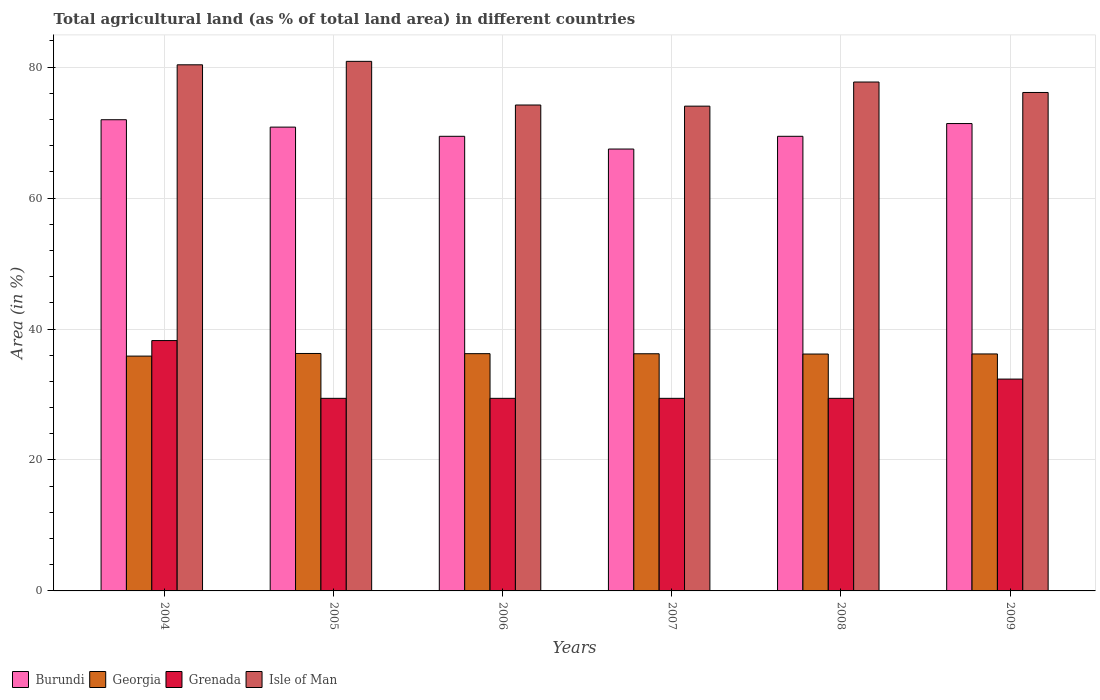Are the number of bars per tick equal to the number of legend labels?
Keep it short and to the point. Yes. How many bars are there on the 6th tick from the left?
Offer a very short reply. 4. What is the label of the 6th group of bars from the left?
Offer a very short reply. 2009. What is the percentage of agricultural land in Burundi in 2007?
Offer a terse response. 67.48. Across all years, what is the maximum percentage of agricultural land in Grenada?
Your response must be concise. 38.24. Across all years, what is the minimum percentage of agricultural land in Georgia?
Your answer should be compact. 35.86. In which year was the percentage of agricultural land in Grenada minimum?
Your response must be concise. 2005. What is the total percentage of agricultural land in Georgia in the graph?
Make the answer very short. 216.95. What is the difference between the percentage of agricultural land in Burundi in 2005 and that in 2008?
Your answer should be very brief. 1.4. What is the difference between the percentage of agricultural land in Burundi in 2007 and the percentage of agricultural land in Georgia in 2009?
Offer a very short reply. 31.29. What is the average percentage of agricultural land in Burundi per year?
Your answer should be compact. 70.09. In the year 2008, what is the difference between the percentage of agricultural land in Burundi and percentage of agricultural land in Georgia?
Offer a terse response. 33.25. What is the ratio of the percentage of agricultural land in Burundi in 2005 to that in 2008?
Give a very brief answer. 1.02. Is the percentage of agricultural land in Isle of Man in 2005 less than that in 2006?
Your answer should be compact. No. Is the difference between the percentage of agricultural land in Burundi in 2005 and 2007 greater than the difference between the percentage of agricultural land in Georgia in 2005 and 2007?
Provide a short and direct response. Yes. What is the difference between the highest and the second highest percentage of agricultural land in Isle of Man?
Offer a terse response. 0.53. What is the difference between the highest and the lowest percentage of agricultural land in Georgia?
Offer a terse response. 0.4. Is it the case that in every year, the sum of the percentage of agricultural land in Burundi and percentage of agricultural land in Georgia is greater than the sum of percentage of agricultural land in Isle of Man and percentage of agricultural land in Grenada?
Offer a terse response. Yes. What does the 4th bar from the left in 2006 represents?
Make the answer very short. Isle of Man. What does the 4th bar from the right in 2008 represents?
Your response must be concise. Burundi. Are all the bars in the graph horizontal?
Keep it short and to the point. No. How many years are there in the graph?
Your response must be concise. 6. Are the values on the major ticks of Y-axis written in scientific E-notation?
Give a very brief answer. No. Does the graph contain any zero values?
Ensure brevity in your answer.  No. How many legend labels are there?
Provide a succinct answer. 4. How are the legend labels stacked?
Make the answer very short. Horizontal. What is the title of the graph?
Keep it short and to the point. Total agricultural land (as % of total land area) in different countries. Does "Algeria" appear as one of the legend labels in the graph?
Your answer should be compact. No. What is the label or title of the X-axis?
Provide a succinct answer. Years. What is the label or title of the Y-axis?
Provide a short and direct response. Area (in %). What is the Area (in %) in Burundi in 2004?
Your answer should be compact. 71.96. What is the Area (in %) in Georgia in 2004?
Provide a short and direct response. 35.86. What is the Area (in %) in Grenada in 2004?
Keep it short and to the point. 38.24. What is the Area (in %) in Isle of Man in 2004?
Offer a very short reply. 80.35. What is the Area (in %) of Burundi in 2005?
Offer a terse response. 70.83. What is the Area (in %) in Georgia in 2005?
Give a very brief answer. 36.26. What is the Area (in %) in Grenada in 2005?
Provide a succinct answer. 29.41. What is the Area (in %) in Isle of Man in 2005?
Your answer should be very brief. 80.88. What is the Area (in %) of Burundi in 2006?
Offer a terse response. 69.43. What is the Area (in %) in Georgia in 2006?
Give a very brief answer. 36.24. What is the Area (in %) in Grenada in 2006?
Give a very brief answer. 29.41. What is the Area (in %) in Isle of Man in 2006?
Provide a succinct answer. 74.21. What is the Area (in %) of Burundi in 2007?
Your response must be concise. 67.48. What is the Area (in %) in Georgia in 2007?
Offer a very short reply. 36.22. What is the Area (in %) in Grenada in 2007?
Your answer should be compact. 29.41. What is the Area (in %) in Isle of Man in 2007?
Your answer should be very brief. 74.04. What is the Area (in %) in Burundi in 2008?
Give a very brief answer. 69.43. What is the Area (in %) of Georgia in 2008?
Make the answer very short. 36.18. What is the Area (in %) in Grenada in 2008?
Ensure brevity in your answer.  29.41. What is the Area (in %) in Isle of Man in 2008?
Offer a terse response. 77.72. What is the Area (in %) in Burundi in 2009?
Your answer should be very brief. 71.38. What is the Area (in %) in Georgia in 2009?
Make the answer very short. 36.19. What is the Area (in %) in Grenada in 2009?
Make the answer very short. 32.35. What is the Area (in %) of Isle of Man in 2009?
Offer a very short reply. 76.12. Across all years, what is the maximum Area (in %) in Burundi?
Give a very brief answer. 71.96. Across all years, what is the maximum Area (in %) of Georgia?
Ensure brevity in your answer.  36.26. Across all years, what is the maximum Area (in %) of Grenada?
Ensure brevity in your answer.  38.24. Across all years, what is the maximum Area (in %) of Isle of Man?
Your response must be concise. 80.88. Across all years, what is the minimum Area (in %) in Burundi?
Provide a succinct answer. 67.48. Across all years, what is the minimum Area (in %) of Georgia?
Make the answer very short. 35.86. Across all years, what is the minimum Area (in %) of Grenada?
Keep it short and to the point. 29.41. Across all years, what is the minimum Area (in %) in Isle of Man?
Give a very brief answer. 74.04. What is the total Area (in %) of Burundi in the graph?
Offer a terse response. 420.52. What is the total Area (in %) of Georgia in the graph?
Ensure brevity in your answer.  216.95. What is the total Area (in %) of Grenada in the graph?
Make the answer very short. 188.24. What is the total Area (in %) of Isle of Man in the graph?
Keep it short and to the point. 463.32. What is the difference between the Area (in %) of Burundi in 2004 and that in 2005?
Offer a very short reply. 1.13. What is the difference between the Area (in %) of Georgia in 2004 and that in 2005?
Your response must be concise. -0.4. What is the difference between the Area (in %) in Grenada in 2004 and that in 2005?
Ensure brevity in your answer.  8.82. What is the difference between the Area (in %) in Isle of Man in 2004 and that in 2005?
Your response must be concise. -0.53. What is the difference between the Area (in %) in Burundi in 2004 and that in 2006?
Your answer should be very brief. 2.53. What is the difference between the Area (in %) of Georgia in 2004 and that in 2006?
Offer a terse response. -0.37. What is the difference between the Area (in %) in Grenada in 2004 and that in 2006?
Offer a terse response. 8.82. What is the difference between the Area (in %) in Isle of Man in 2004 and that in 2006?
Offer a very short reply. 6.14. What is the difference between the Area (in %) of Burundi in 2004 and that in 2007?
Your answer should be compact. 4.48. What is the difference between the Area (in %) in Georgia in 2004 and that in 2007?
Provide a succinct answer. -0.36. What is the difference between the Area (in %) of Grenada in 2004 and that in 2007?
Provide a succinct answer. 8.82. What is the difference between the Area (in %) of Isle of Man in 2004 and that in 2007?
Provide a succinct answer. 6.32. What is the difference between the Area (in %) in Burundi in 2004 and that in 2008?
Provide a succinct answer. 2.53. What is the difference between the Area (in %) in Georgia in 2004 and that in 2008?
Make the answer very short. -0.32. What is the difference between the Area (in %) of Grenada in 2004 and that in 2008?
Ensure brevity in your answer.  8.82. What is the difference between the Area (in %) in Isle of Man in 2004 and that in 2008?
Your answer should be compact. 2.63. What is the difference between the Area (in %) in Burundi in 2004 and that in 2009?
Provide a succinct answer. 0.58. What is the difference between the Area (in %) of Georgia in 2004 and that in 2009?
Make the answer very short. -0.33. What is the difference between the Area (in %) of Grenada in 2004 and that in 2009?
Make the answer very short. 5.88. What is the difference between the Area (in %) of Isle of Man in 2004 and that in 2009?
Your answer should be very brief. 4.23. What is the difference between the Area (in %) in Burundi in 2005 and that in 2006?
Offer a very short reply. 1.4. What is the difference between the Area (in %) of Georgia in 2005 and that in 2006?
Give a very brief answer. 0.03. What is the difference between the Area (in %) in Burundi in 2005 and that in 2007?
Offer a very short reply. 3.35. What is the difference between the Area (in %) in Georgia in 2005 and that in 2007?
Provide a short and direct response. 0.04. What is the difference between the Area (in %) of Isle of Man in 2005 and that in 2007?
Offer a very short reply. 6.84. What is the difference between the Area (in %) in Burundi in 2005 and that in 2008?
Your answer should be very brief. 1.4. What is the difference between the Area (in %) of Georgia in 2005 and that in 2008?
Your answer should be very brief. 0.09. What is the difference between the Area (in %) of Isle of Man in 2005 and that in 2008?
Provide a succinct answer. 3.16. What is the difference between the Area (in %) in Burundi in 2005 and that in 2009?
Your answer should be very brief. -0.55. What is the difference between the Area (in %) of Georgia in 2005 and that in 2009?
Give a very brief answer. 0.07. What is the difference between the Area (in %) in Grenada in 2005 and that in 2009?
Provide a succinct answer. -2.94. What is the difference between the Area (in %) of Isle of Man in 2005 and that in 2009?
Your answer should be very brief. 4.75. What is the difference between the Area (in %) of Burundi in 2006 and that in 2007?
Ensure brevity in your answer.  1.95. What is the difference between the Area (in %) of Georgia in 2006 and that in 2007?
Offer a very short reply. 0.01. What is the difference between the Area (in %) of Grenada in 2006 and that in 2007?
Your response must be concise. 0. What is the difference between the Area (in %) of Isle of Man in 2006 and that in 2007?
Provide a succinct answer. 0.18. What is the difference between the Area (in %) of Georgia in 2006 and that in 2008?
Provide a short and direct response. 0.06. What is the difference between the Area (in %) of Grenada in 2006 and that in 2008?
Give a very brief answer. 0. What is the difference between the Area (in %) of Isle of Man in 2006 and that in 2008?
Your response must be concise. -3.51. What is the difference between the Area (in %) of Burundi in 2006 and that in 2009?
Your answer should be very brief. -1.95. What is the difference between the Area (in %) in Georgia in 2006 and that in 2009?
Offer a very short reply. 0.04. What is the difference between the Area (in %) in Grenada in 2006 and that in 2009?
Offer a terse response. -2.94. What is the difference between the Area (in %) in Isle of Man in 2006 and that in 2009?
Ensure brevity in your answer.  -1.91. What is the difference between the Area (in %) of Burundi in 2007 and that in 2008?
Keep it short and to the point. -1.95. What is the difference between the Area (in %) in Georgia in 2007 and that in 2008?
Offer a terse response. 0.04. What is the difference between the Area (in %) in Isle of Man in 2007 and that in 2008?
Provide a short and direct response. -3.68. What is the difference between the Area (in %) of Burundi in 2007 and that in 2009?
Your answer should be compact. -3.89. What is the difference between the Area (in %) in Georgia in 2007 and that in 2009?
Offer a terse response. 0.03. What is the difference between the Area (in %) of Grenada in 2007 and that in 2009?
Ensure brevity in your answer.  -2.94. What is the difference between the Area (in %) of Isle of Man in 2007 and that in 2009?
Provide a succinct answer. -2.09. What is the difference between the Area (in %) in Burundi in 2008 and that in 2009?
Offer a terse response. -1.95. What is the difference between the Area (in %) in Georgia in 2008 and that in 2009?
Provide a short and direct response. -0.01. What is the difference between the Area (in %) in Grenada in 2008 and that in 2009?
Keep it short and to the point. -2.94. What is the difference between the Area (in %) in Isle of Man in 2008 and that in 2009?
Provide a short and direct response. 1.6. What is the difference between the Area (in %) in Burundi in 2004 and the Area (in %) in Georgia in 2005?
Give a very brief answer. 35.7. What is the difference between the Area (in %) in Burundi in 2004 and the Area (in %) in Grenada in 2005?
Provide a short and direct response. 42.55. What is the difference between the Area (in %) in Burundi in 2004 and the Area (in %) in Isle of Man in 2005?
Ensure brevity in your answer.  -8.91. What is the difference between the Area (in %) of Georgia in 2004 and the Area (in %) of Grenada in 2005?
Provide a succinct answer. 6.45. What is the difference between the Area (in %) of Georgia in 2004 and the Area (in %) of Isle of Man in 2005?
Offer a very short reply. -45.02. What is the difference between the Area (in %) of Grenada in 2004 and the Area (in %) of Isle of Man in 2005?
Ensure brevity in your answer.  -42.64. What is the difference between the Area (in %) in Burundi in 2004 and the Area (in %) in Georgia in 2006?
Your response must be concise. 35.73. What is the difference between the Area (in %) in Burundi in 2004 and the Area (in %) in Grenada in 2006?
Offer a terse response. 42.55. What is the difference between the Area (in %) in Burundi in 2004 and the Area (in %) in Isle of Man in 2006?
Offer a very short reply. -2.25. What is the difference between the Area (in %) of Georgia in 2004 and the Area (in %) of Grenada in 2006?
Provide a short and direct response. 6.45. What is the difference between the Area (in %) in Georgia in 2004 and the Area (in %) in Isle of Man in 2006?
Your answer should be very brief. -38.35. What is the difference between the Area (in %) in Grenada in 2004 and the Area (in %) in Isle of Man in 2006?
Keep it short and to the point. -35.98. What is the difference between the Area (in %) of Burundi in 2004 and the Area (in %) of Georgia in 2007?
Offer a terse response. 35.74. What is the difference between the Area (in %) of Burundi in 2004 and the Area (in %) of Grenada in 2007?
Ensure brevity in your answer.  42.55. What is the difference between the Area (in %) in Burundi in 2004 and the Area (in %) in Isle of Man in 2007?
Ensure brevity in your answer.  -2.07. What is the difference between the Area (in %) of Georgia in 2004 and the Area (in %) of Grenada in 2007?
Provide a succinct answer. 6.45. What is the difference between the Area (in %) of Georgia in 2004 and the Area (in %) of Isle of Man in 2007?
Your response must be concise. -38.17. What is the difference between the Area (in %) of Grenada in 2004 and the Area (in %) of Isle of Man in 2007?
Make the answer very short. -35.8. What is the difference between the Area (in %) of Burundi in 2004 and the Area (in %) of Georgia in 2008?
Keep it short and to the point. 35.78. What is the difference between the Area (in %) of Burundi in 2004 and the Area (in %) of Grenada in 2008?
Give a very brief answer. 42.55. What is the difference between the Area (in %) of Burundi in 2004 and the Area (in %) of Isle of Man in 2008?
Give a very brief answer. -5.76. What is the difference between the Area (in %) of Georgia in 2004 and the Area (in %) of Grenada in 2008?
Your answer should be compact. 6.45. What is the difference between the Area (in %) in Georgia in 2004 and the Area (in %) in Isle of Man in 2008?
Offer a very short reply. -41.86. What is the difference between the Area (in %) of Grenada in 2004 and the Area (in %) of Isle of Man in 2008?
Provide a short and direct response. -39.48. What is the difference between the Area (in %) of Burundi in 2004 and the Area (in %) of Georgia in 2009?
Your answer should be compact. 35.77. What is the difference between the Area (in %) in Burundi in 2004 and the Area (in %) in Grenada in 2009?
Your answer should be compact. 39.61. What is the difference between the Area (in %) in Burundi in 2004 and the Area (in %) in Isle of Man in 2009?
Make the answer very short. -4.16. What is the difference between the Area (in %) in Georgia in 2004 and the Area (in %) in Grenada in 2009?
Ensure brevity in your answer.  3.51. What is the difference between the Area (in %) of Georgia in 2004 and the Area (in %) of Isle of Man in 2009?
Provide a succinct answer. -40.26. What is the difference between the Area (in %) in Grenada in 2004 and the Area (in %) in Isle of Man in 2009?
Your answer should be compact. -37.89. What is the difference between the Area (in %) in Burundi in 2005 and the Area (in %) in Georgia in 2006?
Offer a very short reply. 34.6. What is the difference between the Area (in %) in Burundi in 2005 and the Area (in %) in Grenada in 2006?
Keep it short and to the point. 41.42. What is the difference between the Area (in %) of Burundi in 2005 and the Area (in %) of Isle of Man in 2006?
Provide a succinct answer. -3.38. What is the difference between the Area (in %) in Georgia in 2005 and the Area (in %) in Grenada in 2006?
Your response must be concise. 6.85. What is the difference between the Area (in %) of Georgia in 2005 and the Area (in %) of Isle of Man in 2006?
Give a very brief answer. -37.95. What is the difference between the Area (in %) in Grenada in 2005 and the Area (in %) in Isle of Man in 2006?
Offer a very short reply. -44.8. What is the difference between the Area (in %) in Burundi in 2005 and the Area (in %) in Georgia in 2007?
Ensure brevity in your answer.  34.61. What is the difference between the Area (in %) in Burundi in 2005 and the Area (in %) in Grenada in 2007?
Your answer should be very brief. 41.42. What is the difference between the Area (in %) in Burundi in 2005 and the Area (in %) in Isle of Man in 2007?
Keep it short and to the point. -3.2. What is the difference between the Area (in %) of Georgia in 2005 and the Area (in %) of Grenada in 2007?
Keep it short and to the point. 6.85. What is the difference between the Area (in %) in Georgia in 2005 and the Area (in %) in Isle of Man in 2007?
Offer a terse response. -37.77. What is the difference between the Area (in %) in Grenada in 2005 and the Area (in %) in Isle of Man in 2007?
Offer a very short reply. -44.62. What is the difference between the Area (in %) of Burundi in 2005 and the Area (in %) of Georgia in 2008?
Give a very brief answer. 34.66. What is the difference between the Area (in %) of Burundi in 2005 and the Area (in %) of Grenada in 2008?
Ensure brevity in your answer.  41.42. What is the difference between the Area (in %) of Burundi in 2005 and the Area (in %) of Isle of Man in 2008?
Keep it short and to the point. -6.89. What is the difference between the Area (in %) of Georgia in 2005 and the Area (in %) of Grenada in 2008?
Provide a succinct answer. 6.85. What is the difference between the Area (in %) in Georgia in 2005 and the Area (in %) in Isle of Man in 2008?
Provide a succinct answer. -41.46. What is the difference between the Area (in %) in Grenada in 2005 and the Area (in %) in Isle of Man in 2008?
Keep it short and to the point. -48.31. What is the difference between the Area (in %) of Burundi in 2005 and the Area (in %) of Georgia in 2009?
Give a very brief answer. 34.64. What is the difference between the Area (in %) in Burundi in 2005 and the Area (in %) in Grenada in 2009?
Your response must be concise. 38.48. What is the difference between the Area (in %) in Burundi in 2005 and the Area (in %) in Isle of Man in 2009?
Offer a terse response. -5.29. What is the difference between the Area (in %) of Georgia in 2005 and the Area (in %) of Grenada in 2009?
Provide a succinct answer. 3.91. What is the difference between the Area (in %) of Georgia in 2005 and the Area (in %) of Isle of Man in 2009?
Make the answer very short. -39.86. What is the difference between the Area (in %) in Grenada in 2005 and the Area (in %) in Isle of Man in 2009?
Offer a terse response. -46.71. What is the difference between the Area (in %) of Burundi in 2006 and the Area (in %) of Georgia in 2007?
Provide a short and direct response. 33.21. What is the difference between the Area (in %) of Burundi in 2006 and the Area (in %) of Grenada in 2007?
Your response must be concise. 40.02. What is the difference between the Area (in %) in Burundi in 2006 and the Area (in %) in Isle of Man in 2007?
Ensure brevity in your answer.  -4.6. What is the difference between the Area (in %) of Georgia in 2006 and the Area (in %) of Grenada in 2007?
Give a very brief answer. 6.82. What is the difference between the Area (in %) in Georgia in 2006 and the Area (in %) in Isle of Man in 2007?
Ensure brevity in your answer.  -37.8. What is the difference between the Area (in %) in Grenada in 2006 and the Area (in %) in Isle of Man in 2007?
Give a very brief answer. -44.62. What is the difference between the Area (in %) in Burundi in 2006 and the Area (in %) in Georgia in 2008?
Keep it short and to the point. 33.25. What is the difference between the Area (in %) in Burundi in 2006 and the Area (in %) in Grenada in 2008?
Keep it short and to the point. 40.02. What is the difference between the Area (in %) in Burundi in 2006 and the Area (in %) in Isle of Man in 2008?
Give a very brief answer. -8.29. What is the difference between the Area (in %) of Georgia in 2006 and the Area (in %) of Grenada in 2008?
Make the answer very short. 6.82. What is the difference between the Area (in %) of Georgia in 2006 and the Area (in %) of Isle of Man in 2008?
Offer a very short reply. -41.48. What is the difference between the Area (in %) in Grenada in 2006 and the Area (in %) in Isle of Man in 2008?
Offer a terse response. -48.31. What is the difference between the Area (in %) of Burundi in 2006 and the Area (in %) of Georgia in 2009?
Ensure brevity in your answer.  33.24. What is the difference between the Area (in %) of Burundi in 2006 and the Area (in %) of Grenada in 2009?
Keep it short and to the point. 37.08. What is the difference between the Area (in %) of Burundi in 2006 and the Area (in %) of Isle of Man in 2009?
Keep it short and to the point. -6.69. What is the difference between the Area (in %) of Georgia in 2006 and the Area (in %) of Grenada in 2009?
Provide a short and direct response. 3.88. What is the difference between the Area (in %) in Georgia in 2006 and the Area (in %) in Isle of Man in 2009?
Offer a very short reply. -39.89. What is the difference between the Area (in %) in Grenada in 2006 and the Area (in %) in Isle of Man in 2009?
Provide a short and direct response. -46.71. What is the difference between the Area (in %) of Burundi in 2007 and the Area (in %) of Georgia in 2008?
Your response must be concise. 31.31. What is the difference between the Area (in %) of Burundi in 2007 and the Area (in %) of Grenada in 2008?
Your response must be concise. 38.07. What is the difference between the Area (in %) of Burundi in 2007 and the Area (in %) of Isle of Man in 2008?
Provide a succinct answer. -10.23. What is the difference between the Area (in %) in Georgia in 2007 and the Area (in %) in Grenada in 2008?
Give a very brief answer. 6.81. What is the difference between the Area (in %) of Georgia in 2007 and the Area (in %) of Isle of Man in 2008?
Offer a terse response. -41.5. What is the difference between the Area (in %) in Grenada in 2007 and the Area (in %) in Isle of Man in 2008?
Ensure brevity in your answer.  -48.31. What is the difference between the Area (in %) of Burundi in 2007 and the Area (in %) of Georgia in 2009?
Offer a very short reply. 31.29. What is the difference between the Area (in %) in Burundi in 2007 and the Area (in %) in Grenada in 2009?
Offer a very short reply. 35.13. What is the difference between the Area (in %) in Burundi in 2007 and the Area (in %) in Isle of Man in 2009?
Your answer should be very brief. -8.64. What is the difference between the Area (in %) of Georgia in 2007 and the Area (in %) of Grenada in 2009?
Offer a very short reply. 3.87. What is the difference between the Area (in %) in Georgia in 2007 and the Area (in %) in Isle of Man in 2009?
Provide a succinct answer. -39.9. What is the difference between the Area (in %) of Grenada in 2007 and the Area (in %) of Isle of Man in 2009?
Give a very brief answer. -46.71. What is the difference between the Area (in %) in Burundi in 2008 and the Area (in %) in Georgia in 2009?
Offer a very short reply. 33.24. What is the difference between the Area (in %) of Burundi in 2008 and the Area (in %) of Grenada in 2009?
Provide a succinct answer. 37.08. What is the difference between the Area (in %) of Burundi in 2008 and the Area (in %) of Isle of Man in 2009?
Provide a succinct answer. -6.69. What is the difference between the Area (in %) of Georgia in 2008 and the Area (in %) of Grenada in 2009?
Offer a very short reply. 3.82. What is the difference between the Area (in %) of Georgia in 2008 and the Area (in %) of Isle of Man in 2009?
Your answer should be compact. -39.94. What is the difference between the Area (in %) in Grenada in 2008 and the Area (in %) in Isle of Man in 2009?
Your response must be concise. -46.71. What is the average Area (in %) of Burundi per year?
Offer a very short reply. 70.09. What is the average Area (in %) in Georgia per year?
Provide a short and direct response. 36.16. What is the average Area (in %) of Grenada per year?
Offer a very short reply. 31.37. What is the average Area (in %) of Isle of Man per year?
Your response must be concise. 77.22. In the year 2004, what is the difference between the Area (in %) in Burundi and Area (in %) in Georgia?
Make the answer very short. 36.1. In the year 2004, what is the difference between the Area (in %) in Burundi and Area (in %) in Grenada?
Your answer should be very brief. 33.73. In the year 2004, what is the difference between the Area (in %) of Burundi and Area (in %) of Isle of Man?
Your response must be concise. -8.39. In the year 2004, what is the difference between the Area (in %) in Georgia and Area (in %) in Grenada?
Offer a terse response. -2.37. In the year 2004, what is the difference between the Area (in %) of Georgia and Area (in %) of Isle of Man?
Your answer should be very brief. -44.49. In the year 2004, what is the difference between the Area (in %) in Grenada and Area (in %) in Isle of Man?
Offer a very short reply. -42.12. In the year 2005, what is the difference between the Area (in %) of Burundi and Area (in %) of Georgia?
Your answer should be compact. 34.57. In the year 2005, what is the difference between the Area (in %) in Burundi and Area (in %) in Grenada?
Give a very brief answer. 41.42. In the year 2005, what is the difference between the Area (in %) of Burundi and Area (in %) of Isle of Man?
Ensure brevity in your answer.  -10.04. In the year 2005, what is the difference between the Area (in %) in Georgia and Area (in %) in Grenada?
Provide a succinct answer. 6.85. In the year 2005, what is the difference between the Area (in %) of Georgia and Area (in %) of Isle of Man?
Your answer should be compact. -44.61. In the year 2005, what is the difference between the Area (in %) in Grenada and Area (in %) in Isle of Man?
Offer a very short reply. -51.47. In the year 2006, what is the difference between the Area (in %) in Burundi and Area (in %) in Georgia?
Your answer should be very brief. 33.2. In the year 2006, what is the difference between the Area (in %) in Burundi and Area (in %) in Grenada?
Offer a terse response. 40.02. In the year 2006, what is the difference between the Area (in %) in Burundi and Area (in %) in Isle of Man?
Ensure brevity in your answer.  -4.78. In the year 2006, what is the difference between the Area (in %) of Georgia and Area (in %) of Grenada?
Offer a terse response. 6.82. In the year 2006, what is the difference between the Area (in %) in Georgia and Area (in %) in Isle of Man?
Offer a terse response. -37.98. In the year 2006, what is the difference between the Area (in %) in Grenada and Area (in %) in Isle of Man?
Give a very brief answer. -44.8. In the year 2007, what is the difference between the Area (in %) in Burundi and Area (in %) in Georgia?
Offer a terse response. 31.26. In the year 2007, what is the difference between the Area (in %) in Burundi and Area (in %) in Grenada?
Ensure brevity in your answer.  38.07. In the year 2007, what is the difference between the Area (in %) in Burundi and Area (in %) in Isle of Man?
Provide a short and direct response. -6.55. In the year 2007, what is the difference between the Area (in %) of Georgia and Area (in %) of Grenada?
Keep it short and to the point. 6.81. In the year 2007, what is the difference between the Area (in %) of Georgia and Area (in %) of Isle of Man?
Give a very brief answer. -37.81. In the year 2007, what is the difference between the Area (in %) of Grenada and Area (in %) of Isle of Man?
Make the answer very short. -44.62. In the year 2008, what is the difference between the Area (in %) in Burundi and Area (in %) in Georgia?
Keep it short and to the point. 33.25. In the year 2008, what is the difference between the Area (in %) of Burundi and Area (in %) of Grenada?
Offer a very short reply. 40.02. In the year 2008, what is the difference between the Area (in %) in Burundi and Area (in %) in Isle of Man?
Keep it short and to the point. -8.29. In the year 2008, what is the difference between the Area (in %) in Georgia and Area (in %) in Grenada?
Your answer should be very brief. 6.77. In the year 2008, what is the difference between the Area (in %) of Georgia and Area (in %) of Isle of Man?
Give a very brief answer. -41.54. In the year 2008, what is the difference between the Area (in %) of Grenada and Area (in %) of Isle of Man?
Ensure brevity in your answer.  -48.31. In the year 2009, what is the difference between the Area (in %) in Burundi and Area (in %) in Georgia?
Your response must be concise. 35.19. In the year 2009, what is the difference between the Area (in %) of Burundi and Area (in %) of Grenada?
Make the answer very short. 39.03. In the year 2009, what is the difference between the Area (in %) in Burundi and Area (in %) in Isle of Man?
Ensure brevity in your answer.  -4.74. In the year 2009, what is the difference between the Area (in %) in Georgia and Area (in %) in Grenada?
Ensure brevity in your answer.  3.84. In the year 2009, what is the difference between the Area (in %) of Georgia and Area (in %) of Isle of Man?
Provide a succinct answer. -39.93. In the year 2009, what is the difference between the Area (in %) in Grenada and Area (in %) in Isle of Man?
Make the answer very short. -43.77. What is the ratio of the Area (in %) in Burundi in 2004 to that in 2005?
Keep it short and to the point. 1.02. What is the ratio of the Area (in %) of Georgia in 2004 to that in 2005?
Your answer should be very brief. 0.99. What is the ratio of the Area (in %) of Grenada in 2004 to that in 2005?
Give a very brief answer. 1.3. What is the ratio of the Area (in %) in Isle of Man in 2004 to that in 2005?
Provide a short and direct response. 0.99. What is the ratio of the Area (in %) of Burundi in 2004 to that in 2006?
Your answer should be very brief. 1.04. What is the ratio of the Area (in %) of Georgia in 2004 to that in 2006?
Offer a very short reply. 0.99. What is the ratio of the Area (in %) in Grenada in 2004 to that in 2006?
Provide a succinct answer. 1.3. What is the ratio of the Area (in %) in Isle of Man in 2004 to that in 2006?
Make the answer very short. 1.08. What is the ratio of the Area (in %) in Burundi in 2004 to that in 2007?
Give a very brief answer. 1.07. What is the ratio of the Area (in %) in Georgia in 2004 to that in 2007?
Provide a short and direct response. 0.99. What is the ratio of the Area (in %) in Isle of Man in 2004 to that in 2007?
Give a very brief answer. 1.09. What is the ratio of the Area (in %) of Burundi in 2004 to that in 2008?
Provide a short and direct response. 1.04. What is the ratio of the Area (in %) of Georgia in 2004 to that in 2008?
Ensure brevity in your answer.  0.99. What is the ratio of the Area (in %) in Grenada in 2004 to that in 2008?
Give a very brief answer. 1.3. What is the ratio of the Area (in %) in Isle of Man in 2004 to that in 2008?
Give a very brief answer. 1.03. What is the ratio of the Area (in %) in Burundi in 2004 to that in 2009?
Offer a very short reply. 1.01. What is the ratio of the Area (in %) in Georgia in 2004 to that in 2009?
Give a very brief answer. 0.99. What is the ratio of the Area (in %) of Grenada in 2004 to that in 2009?
Make the answer very short. 1.18. What is the ratio of the Area (in %) in Isle of Man in 2004 to that in 2009?
Offer a terse response. 1.06. What is the ratio of the Area (in %) in Burundi in 2005 to that in 2006?
Your response must be concise. 1.02. What is the ratio of the Area (in %) of Isle of Man in 2005 to that in 2006?
Provide a short and direct response. 1.09. What is the ratio of the Area (in %) in Burundi in 2005 to that in 2007?
Provide a short and direct response. 1.05. What is the ratio of the Area (in %) in Georgia in 2005 to that in 2007?
Ensure brevity in your answer.  1. What is the ratio of the Area (in %) of Isle of Man in 2005 to that in 2007?
Your response must be concise. 1.09. What is the ratio of the Area (in %) in Burundi in 2005 to that in 2008?
Your answer should be very brief. 1.02. What is the ratio of the Area (in %) of Isle of Man in 2005 to that in 2008?
Your answer should be very brief. 1.04. What is the ratio of the Area (in %) of Isle of Man in 2005 to that in 2009?
Provide a succinct answer. 1.06. What is the ratio of the Area (in %) in Burundi in 2006 to that in 2007?
Make the answer very short. 1.03. What is the ratio of the Area (in %) in Burundi in 2006 to that in 2008?
Offer a very short reply. 1. What is the ratio of the Area (in %) of Georgia in 2006 to that in 2008?
Offer a very short reply. 1. What is the ratio of the Area (in %) of Isle of Man in 2006 to that in 2008?
Ensure brevity in your answer.  0.95. What is the ratio of the Area (in %) in Burundi in 2006 to that in 2009?
Your answer should be very brief. 0.97. What is the ratio of the Area (in %) of Isle of Man in 2006 to that in 2009?
Ensure brevity in your answer.  0.97. What is the ratio of the Area (in %) in Burundi in 2007 to that in 2008?
Offer a very short reply. 0.97. What is the ratio of the Area (in %) of Georgia in 2007 to that in 2008?
Provide a succinct answer. 1. What is the ratio of the Area (in %) of Isle of Man in 2007 to that in 2008?
Offer a very short reply. 0.95. What is the ratio of the Area (in %) in Burundi in 2007 to that in 2009?
Give a very brief answer. 0.95. What is the ratio of the Area (in %) in Grenada in 2007 to that in 2009?
Your answer should be compact. 0.91. What is the ratio of the Area (in %) of Isle of Man in 2007 to that in 2009?
Give a very brief answer. 0.97. What is the ratio of the Area (in %) in Burundi in 2008 to that in 2009?
Your answer should be compact. 0.97. What is the ratio of the Area (in %) of Isle of Man in 2008 to that in 2009?
Your answer should be very brief. 1.02. What is the difference between the highest and the second highest Area (in %) of Burundi?
Make the answer very short. 0.58. What is the difference between the highest and the second highest Area (in %) of Georgia?
Offer a terse response. 0.03. What is the difference between the highest and the second highest Area (in %) of Grenada?
Provide a succinct answer. 5.88. What is the difference between the highest and the second highest Area (in %) of Isle of Man?
Offer a very short reply. 0.53. What is the difference between the highest and the lowest Area (in %) of Burundi?
Make the answer very short. 4.48. What is the difference between the highest and the lowest Area (in %) in Georgia?
Ensure brevity in your answer.  0.4. What is the difference between the highest and the lowest Area (in %) in Grenada?
Your answer should be very brief. 8.82. What is the difference between the highest and the lowest Area (in %) of Isle of Man?
Your answer should be compact. 6.84. 